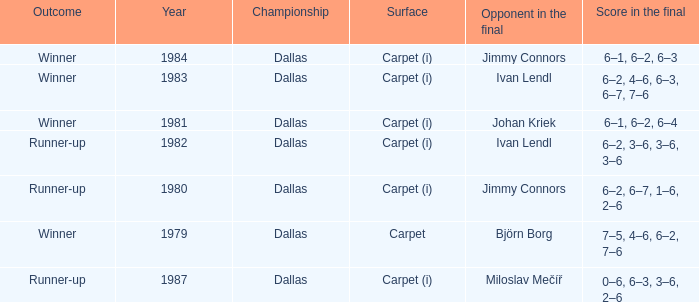What is the number of outcomes listed when johan kriek was the final competitor? 1.0. 